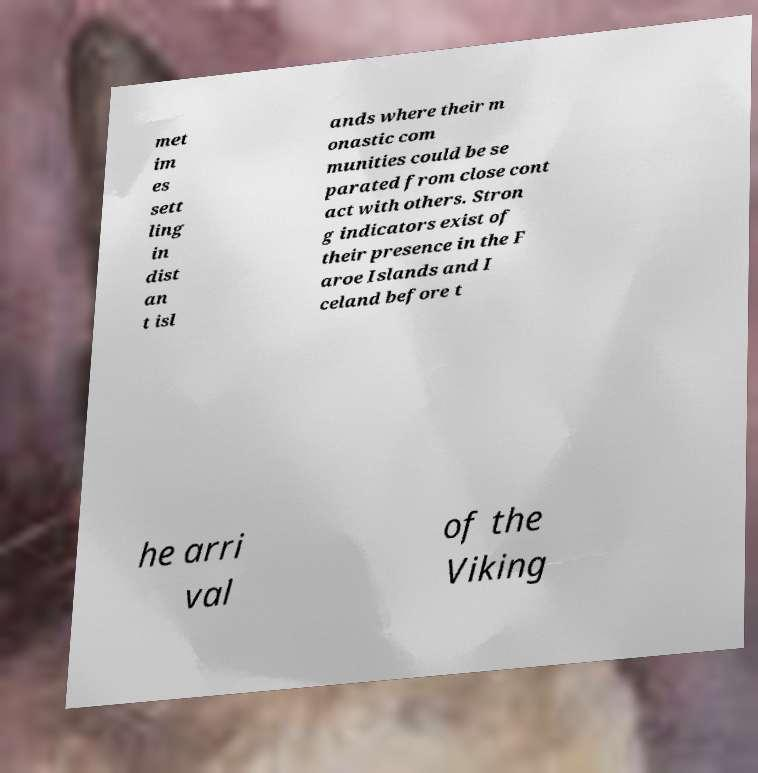Please identify and transcribe the text found in this image. met im es sett ling in dist an t isl ands where their m onastic com munities could be se parated from close cont act with others. Stron g indicators exist of their presence in the F aroe Islands and I celand before t he arri val of the Viking 